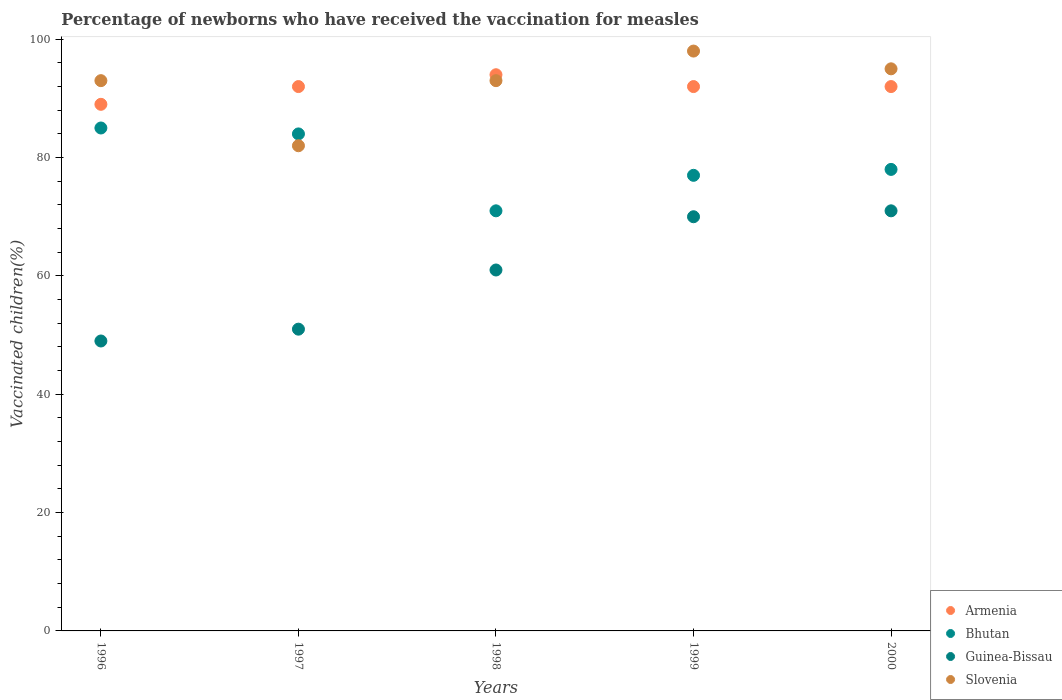How many different coloured dotlines are there?
Your answer should be very brief. 4. Is the number of dotlines equal to the number of legend labels?
Provide a succinct answer. Yes. Across all years, what is the maximum percentage of vaccinated children in Slovenia?
Provide a short and direct response. 98. In which year was the percentage of vaccinated children in Bhutan maximum?
Your answer should be compact. 1996. In which year was the percentage of vaccinated children in Guinea-Bissau minimum?
Your answer should be compact. 1996. What is the total percentage of vaccinated children in Armenia in the graph?
Give a very brief answer. 459. What is the difference between the percentage of vaccinated children in Armenia in 1998 and that in 2000?
Your answer should be compact. 2. What is the average percentage of vaccinated children in Slovenia per year?
Keep it short and to the point. 92.2. In the year 1998, what is the difference between the percentage of vaccinated children in Armenia and percentage of vaccinated children in Slovenia?
Ensure brevity in your answer.  1. What is the ratio of the percentage of vaccinated children in Guinea-Bissau in 1999 to that in 2000?
Give a very brief answer. 0.99. What is the difference between the highest and the second highest percentage of vaccinated children in Bhutan?
Provide a short and direct response. 1. What is the difference between the highest and the lowest percentage of vaccinated children in Guinea-Bissau?
Ensure brevity in your answer.  22. Is it the case that in every year, the sum of the percentage of vaccinated children in Guinea-Bissau and percentage of vaccinated children in Armenia  is greater than the percentage of vaccinated children in Slovenia?
Offer a very short reply. Yes. Does the percentage of vaccinated children in Slovenia monotonically increase over the years?
Ensure brevity in your answer.  No. Is the percentage of vaccinated children in Armenia strictly greater than the percentage of vaccinated children in Guinea-Bissau over the years?
Make the answer very short. Yes. Is the percentage of vaccinated children in Armenia strictly less than the percentage of vaccinated children in Slovenia over the years?
Your answer should be very brief. No. How many years are there in the graph?
Keep it short and to the point. 5. How many legend labels are there?
Provide a short and direct response. 4. What is the title of the graph?
Ensure brevity in your answer.  Percentage of newborns who have received the vaccination for measles. Does "Small states" appear as one of the legend labels in the graph?
Keep it short and to the point. No. What is the label or title of the Y-axis?
Offer a terse response. Vaccinated children(%). What is the Vaccinated children(%) in Armenia in 1996?
Ensure brevity in your answer.  89. What is the Vaccinated children(%) of Slovenia in 1996?
Provide a short and direct response. 93. What is the Vaccinated children(%) of Armenia in 1997?
Offer a terse response. 92. What is the Vaccinated children(%) of Bhutan in 1997?
Offer a very short reply. 84. What is the Vaccinated children(%) in Armenia in 1998?
Ensure brevity in your answer.  94. What is the Vaccinated children(%) of Bhutan in 1998?
Ensure brevity in your answer.  71. What is the Vaccinated children(%) of Slovenia in 1998?
Your answer should be very brief. 93. What is the Vaccinated children(%) of Armenia in 1999?
Offer a very short reply. 92. What is the Vaccinated children(%) of Bhutan in 1999?
Keep it short and to the point. 77. What is the Vaccinated children(%) in Guinea-Bissau in 1999?
Make the answer very short. 70. What is the Vaccinated children(%) of Armenia in 2000?
Provide a succinct answer. 92. What is the Vaccinated children(%) of Bhutan in 2000?
Provide a succinct answer. 78. What is the Vaccinated children(%) of Slovenia in 2000?
Your answer should be very brief. 95. Across all years, what is the maximum Vaccinated children(%) in Armenia?
Your answer should be very brief. 94. Across all years, what is the maximum Vaccinated children(%) in Guinea-Bissau?
Give a very brief answer. 71. Across all years, what is the maximum Vaccinated children(%) in Slovenia?
Offer a very short reply. 98. Across all years, what is the minimum Vaccinated children(%) of Armenia?
Offer a very short reply. 89. Across all years, what is the minimum Vaccinated children(%) of Slovenia?
Offer a very short reply. 82. What is the total Vaccinated children(%) in Armenia in the graph?
Your answer should be compact. 459. What is the total Vaccinated children(%) of Bhutan in the graph?
Make the answer very short. 395. What is the total Vaccinated children(%) of Guinea-Bissau in the graph?
Ensure brevity in your answer.  302. What is the total Vaccinated children(%) of Slovenia in the graph?
Your response must be concise. 461. What is the difference between the Vaccinated children(%) of Armenia in 1996 and that in 1997?
Keep it short and to the point. -3. What is the difference between the Vaccinated children(%) in Bhutan in 1996 and that in 1997?
Offer a terse response. 1. What is the difference between the Vaccinated children(%) of Slovenia in 1996 and that in 1997?
Keep it short and to the point. 11. What is the difference between the Vaccinated children(%) in Guinea-Bissau in 1996 and that in 1998?
Provide a short and direct response. -12. What is the difference between the Vaccinated children(%) in Armenia in 1996 and that in 1999?
Give a very brief answer. -3. What is the difference between the Vaccinated children(%) in Guinea-Bissau in 1996 and that in 1999?
Offer a terse response. -21. What is the difference between the Vaccinated children(%) in Armenia in 1996 and that in 2000?
Your response must be concise. -3. What is the difference between the Vaccinated children(%) in Armenia in 1997 and that in 1998?
Offer a very short reply. -2. What is the difference between the Vaccinated children(%) in Armenia in 1997 and that in 1999?
Your response must be concise. 0. What is the difference between the Vaccinated children(%) in Armenia in 1998 and that in 1999?
Your answer should be very brief. 2. What is the difference between the Vaccinated children(%) in Bhutan in 1998 and that in 1999?
Offer a very short reply. -6. What is the difference between the Vaccinated children(%) of Guinea-Bissau in 1998 and that in 1999?
Provide a short and direct response. -9. What is the difference between the Vaccinated children(%) of Slovenia in 1998 and that in 1999?
Ensure brevity in your answer.  -5. What is the difference between the Vaccinated children(%) of Bhutan in 1998 and that in 2000?
Give a very brief answer. -7. What is the difference between the Vaccinated children(%) in Guinea-Bissau in 1998 and that in 2000?
Keep it short and to the point. -10. What is the difference between the Vaccinated children(%) in Armenia in 1999 and that in 2000?
Offer a very short reply. 0. What is the difference between the Vaccinated children(%) in Slovenia in 1999 and that in 2000?
Ensure brevity in your answer.  3. What is the difference between the Vaccinated children(%) in Armenia in 1996 and the Vaccinated children(%) in Bhutan in 1997?
Offer a very short reply. 5. What is the difference between the Vaccinated children(%) in Armenia in 1996 and the Vaccinated children(%) in Slovenia in 1997?
Provide a succinct answer. 7. What is the difference between the Vaccinated children(%) in Bhutan in 1996 and the Vaccinated children(%) in Slovenia in 1997?
Offer a terse response. 3. What is the difference between the Vaccinated children(%) of Guinea-Bissau in 1996 and the Vaccinated children(%) of Slovenia in 1997?
Offer a very short reply. -33. What is the difference between the Vaccinated children(%) in Bhutan in 1996 and the Vaccinated children(%) in Guinea-Bissau in 1998?
Provide a short and direct response. 24. What is the difference between the Vaccinated children(%) of Bhutan in 1996 and the Vaccinated children(%) of Slovenia in 1998?
Provide a succinct answer. -8. What is the difference between the Vaccinated children(%) of Guinea-Bissau in 1996 and the Vaccinated children(%) of Slovenia in 1998?
Your response must be concise. -44. What is the difference between the Vaccinated children(%) in Armenia in 1996 and the Vaccinated children(%) in Bhutan in 1999?
Ensure brevity in your answer.  12. What is the difference between the Vaccinated children(%) of Armenia in 1996 and the Vaccinated children(%) of Slovenia in 1999?
Offer a terse response. -9. What is the difference between the Vaccinated children(%) in Guinea-Bissau in 1996 and the Vaccinated children(%) in Slovenia in 1999?
Make the answer very short. -49. What is the difference between the Vaccinated children(%) of Bhutan in 1996 and the Vaccinated children(%) of Slovenia in 2000?
Make the answer very short. -10. What is the difference between the Vaccinated children(%) in Guinea-Bissau in 1996 and the Vaccinated children(%) in Slovenia in 2000?
Ensure brevity in your answer.  -46. What is the difference between the Vaccinated children(%) of Armenia in 1997 and the Vaccinated children(%) of Bhutan in 1998?
Offer a very short reply. 21. What is the difference between the Vaccinated children(%) in Armenia in 1997 and the Vaccinated children(%) in Slovenia in 1998?
Your answer should be very brief. -1. What is the difference between the Vaccinated children(%) of Guinea-Bissau in 1997 and the Vaccinated children(%) of Slovenia in 1998?
Make the answer very short. -42. What is the difference between the Vaccinated children(%) of Bhutan in 1997 and the Vaccinated children(%) of Slovenia in 1999?
Offer a very short reply. -14. What is the difference between the Vaccinated children(%) of Guinea-Bissau in 1997 and the Vaccinated children(%) of Slovenia in 1999?
Your response must be concise. -47. What is the difference between the Vaccinated children(%) of Armenia in 1997 and the Vaccinated children(%) of Bhutan in 2000?
Ensure brevity in your answer.  14. What is the difference between the Vaccinated children(%) of Armenia in 1997 and the Vaccinated children(%) of Slovenia in 2000?
Provide a short and direct response. -3. What is the difference between the Vaccinated children(%) in Bhutan in 1997 and the Vaccinated children(%) in Guinea-Bissau in 2000?
Offer a very short reply. 13. What is the difference between the Vaccinated children(%) of Guinea-Bissau in 1997 and the Vaccinated children(%) of Slovenia in 2000?
Your response must be concise. -44. What is the difference between the Vaccinated children(%) of Armenia in 1998 and the Vaccinated children(%) of Bhutan in 1999?
Your answer should be compact. 17. What is the difference between the Vaccinated children(%) in Armenia in 1998 and the Vaccinated children(%) in Slovenia in 1999?
Your answer should be compact. -4. What is the difference between the Vaccinated children(%) in Bhutan in 1998 and the Vaccinated children(%) in Slovenia in 1999?
Offer a very short reply. -27. What is the difference between the Vaccinated children(%) in Guinea-Bissau in 1998 and the Vaccinated children(%) in Slovenia in 1999?
Provide a succinct answer. -37. What is the difference between the Vaccinated children(%) of Guinea-Bissau in 1998 and the Vaccinated children(%) of Slovenia in 2000?
Provide a short and direct response. -34. What is the difference between the Vaccinated children(%) of Armenia in 1999 and the Vaccinated children(%) of Guinea-Bissau in 2000?
Your answer should be compact. 21. What is the difference between the Vaccinated children(%) in Armenia in 1999 and the Vaccinated children(%) in Slovenia in 2000?
Provide a succinct answer. -3. What is the difference between the Vaccinated children(%) in Bhutan in 1999 and the Vaccinated children(%) in Guinea-Bissau in 2000?
Your response must be concise. 6. What is the average Vaccinated children(%) of Armenia per year?
Give a very brief answer. 91.8. What is the average Vaccinated children(%) of Bhutan per year?
Provide a short and direct response. 79. What is the average Vaccinated children(%) in Guinea-Bissau per year?
Give a very brief answer. 60.4. What is the average Vaccinated children(%) of Slovenia per year?
Provide a succinct answer. 92.2. In the year 1996, what is the difference between the Vaccinated children(%) of Armenia and Vaccinated children(%) of Bhutan?
Keep it short and to the point. 4. In the year 1996, what is the difference between the Vaccinated children(%) of Armenia and Vaccinated children(%) of Slovenia?
Give a very brief answer. -4. In the year 1996, what is the difference between the Vaccinated children(%) of Bhutan and Vaccinated children(%) of Guinea-Bissau?
Provide a succinct answer. 36. In the year 1996, what is the difference between the Vaccinated children(%) of Guinea-Bissau and Vaccinated children(%) of Slovenia?
Your response must be concise. -44. In the year 1997, what is the difference between the Vaccinated children(%) of Armenia and Vaccinated children(%) of Bhutan?
Provide a short and direct response. 8. In the year 1997, what is the difference between the Vaccinated children(%) in Bhutan and Vaccinated children(%) in Slovenia?
Provide a short and direct response. 2. In the year 1997, what is the difference between the Vaccinated children(%) in Guinea-Bissau and Vaccinated children(%) in Slovenia?
Your answer should be compact. -31. In the year 1998, what is the difference between the Vaccinated children(%) in Armenia and Vaccinated children(%) in Bhutan?
Offer a terse response. 23. In the year 1998, what is the difference between the Vaccinated children(%) of Armenia and Vaccinated children(%) of Guinea-Bissau?
Ensure brevity in your answer.  33. In the year 1998, what is the difference between the Vaccinated children(%) of Armenia and Vaccinated children(%) of Slovenia?
Offer a very short reply. 1. In the year 1998, what is the difference between the Vaccinated children(%) in Bhutan and Vaccinated children(%) in Slovenia?
Provide a short and direct response. -22. In the year 1998, what is the difference between the Vaccinated children(%) in Guinea-Bissau and Vaccinated children(%) in Slovenia?
Provide a short and direct response. -32. In the year 1999, what is the difference between the Vaccinated children(%) in Armenia and Vaccinated children(%) in Bhutan?
Your response must be concise. 15. In the year 1999, what is the difference between the Vaccinated children(%) of Armenia and Vaccinated children(%) of Guinea-Bissau?
Offer a very short reply. 22. In the year 1999, what is the difference between the Vaccinated children(%) of Armenia and Vaccinated children(%) of Slovenia?
Your answer should be compact. -6. In the year 1999, what is the difference between the Vaccinated children(%) of Bhutan and Vaccinated children(%) of Guinea-Bissau?
Make the answer very short. 7. In the year 1999, what is the difference between the Vaccinated children(%) in Guinea-Bissau and Vaccinated children(%) in Slovenia?
Provide a short and direct response. -28. In the year 2000, what is the difference between the Vaccinated children(%) of Armenia and Vaccinated children(%) of Bhutan?
Your answer should be very brief. 14. In the year 2000, what is the difference between the Vaccinated children(%) in Armenia and Vaccinated children(%) in Guinea-Bissau?
Give a very brief answer. 21. In the year 2000, what is the difference between the Vaccinated children(%) of Bhutan and Vaccinated children(%) of Guinea-Bissau?
Provide a short and direct response. 7. What is the ratio of the Vaccinated children(%) of Armenia in 1996 to that in 1997?
Provide a short and direct response. 0.97. What is the ratio of the Vaccinated children(%) of Bhutan in 1996 to that in 1997?
Your response must be concise. 1.01. What is the ratio of the Vaccinated children(%) in Guinea-Bissau in 1996 to that in 1997?
Ensure brevity in your answer.  0.96. What is the ratio of the Vaccinated children(%) of Slovenia in 1996 to that in 1997?
Provide a succinct answer. 1.13. What is the ratio of the Vaccinated children(%) in Armenia in 1996 to that in 1998?
Your answer should be compact. 0.95. What is the ratio of the Vaccinated children(%) of Bhutan in 1996 to that in 1998?
Offer a terse response. 1.2. What is the ratio of the Vaccinated children(%) of Guinea-Bissau in 1996 to that in 1998?
Make the answer very short. 0.8. What is the ratio of the Vaccinated children(%) of Armenia in 1996 to that in 1999?
Offer a terse response. 0.97. What is the ratio of the Vaccinated children(%) in Bhutan in 1996 to that in 1999?
Your response must be concise. 1.1. What is the ratio of the Vaccinated children(%) in Slovenia in 1996 to that in 1999?
Keep it short and to the point. 0.95. What is the ratio of the Vaccinated children(%) in Armenia in 1996 to that in 2000?
Keep it short and to the point. 0.97. What is the ratio of the Vaccinated children(%) in Bhutan in 1996 to that in 2000?
Give a very brief answer. 1.09. What is the ratio of the Vaccinated children(%) in Guinea-Bissau in 1996 to that in 2000?
Give a very brief answer. 0.69. What is the ratio of the Vaccinated children(%) in Slovenia in 1996 to that in 2000?
Provide a short and direct response. 0.98. What is the ratio of the Vaccinated children(%) of Armenia in 1997 to that in 1998?
Offer a terse response. 0.98. What is the ratio of the Vaccinated children(%) in Bhutan in 1997 to that in 1998?
Offer a terse response. 1.18. What is the ratio of the Vaccinated children(%) of Guinea-Bissau in 1997 to that in 1998?
Ensure brevity in your answer.  0.84. What is the ratio of the Vaccinated children(%) in Slovenia in 1997 to that in 1998?
Provide a succinct answer. 0.88. What is the ratio of the Vaccinated children(%) in Armenia in 1997 to that in 1999?
Provide a short and direct response. 1. What is the ratio of the Vaccinated children(%) in Bhutan in 1997 to that in 1999?
Offer a terse response. 1.09. What is the ratio of the Vaccinated children(%) in Guinea-Bissau in 1997 to that in 1999?
Provide a short and direct response. 0.73. What is the ratio of the Vaccinated children(%) in Slovenia in 1997 to that in 1999?
Provide a short and direct response. 0.84. What is the ratio of the Vaccinated children(%) in Armenia in 1997 to that in 2000?
Keep it short and to the point. 1. What is the ratio of the Vaccinated children(%) of Bhutan in 1997 to that in 2000?
Give a very brief answer. 1.08. What is the ratio of the Vaccinated children(%) of Guinea-Bissau in 1997 to that in 2000?
Keep it short and to the point. 0.72. What is the ratio of the Vaccinated children(%) in Slovenia in 1997 to that in 2000?
Make the answer very short. 0.86. What is the ratio of the Vaccinated children(%) of Armenia in 1998 to that in 1999?
Give a very brief answer. 1.02. What is the ratio of the Vaccinated children(%) in Bhutan in 1998 to that in 1999?
Make the answer very short. 0.92. What is the ratio of the Vaccinated children(%) in Guinea-Bissau in 1998 to that in 1999?
Offer a terse response. 0.87. What is the ratio of the Vaccinated children(%) of Slovenia in 1998 to that in 1999?
Provide a short and direct response. 0.95. What is the ratio of the Vaccinated children(%) in Armenia in 1998 to that in 2000?
Offer a very short reply. 1.02. What is the ratio of the Vaccinated children(%) in Bhutan in 1998 to that in 2000?
Ensure brevity in your answer.  0.91. What is the ratio of the Vaccinated children(%) of Guinea-Bissau in 1998 to that in 2000?
Your answer should be compact. 0.86. What is the ratio of the Vaccinated children(%) in Slovenia in 1998 to that in 2000?
Offer a very short reply. 0.98. What is the ratio of the Vaccinated children(%) in Bhutan in 1999 to that in 2000?
Your answer should be compact. 0.99. What is the ratio of the Vaccinated children(%) in Guinea-Bissau in 1999 to that in 2000?
Keep it short and to the point. 0.99. What is the ratio of the Vaccinated children(%) of Slovenia in 1999 to that in 2000?
Give a very brief answer. 1.03. What is the difference between the highest and the second highest Vaccinated children(%) of Armenia?
Keep it short and to the point. 2. What is the difference between the highest and the second highest Vaccinated children(%) in Bhutan?
Offer a terse response. 1. What is the difference between the highest and the second highest Vaccinated children(%) in Guinea-Bissau?
Give a very brief answer. 1. What is the difference between the highest and the lowest Vaccinated children(%) of Armenia?
Provide a succinct answer. 5. What is the difference between the highest and the lowest Vaccinated children(%) in Guinea-Bissau?
Give a very brief answer. 22. What is the difference between the highest and the lowest Vaccinated children(%) in Slovenia?
Your answer should be very brief. 16. 